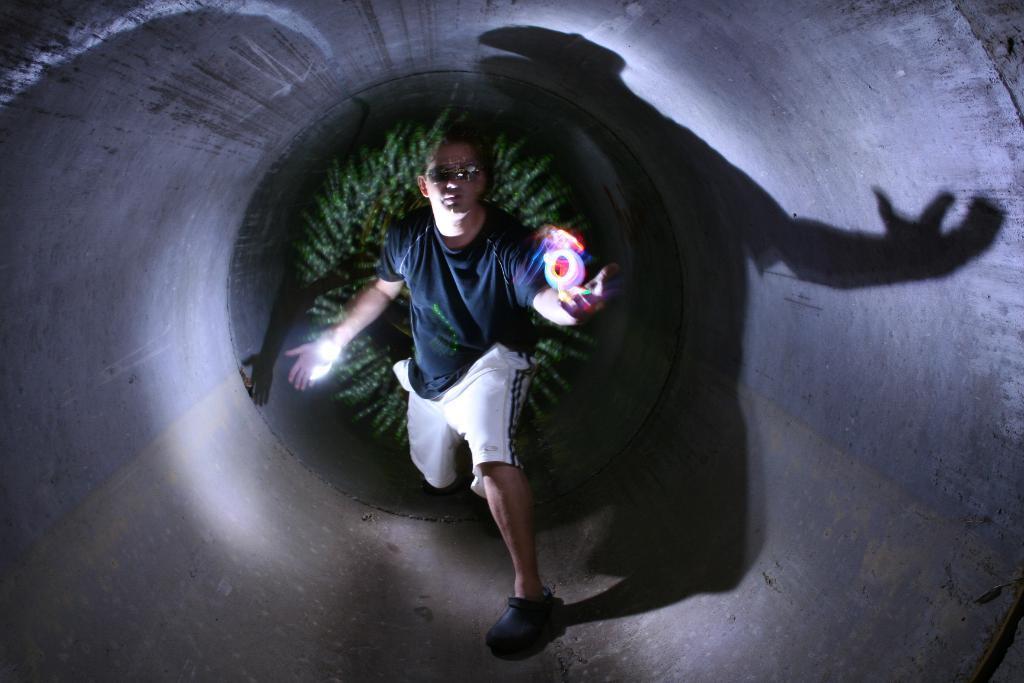Could you give a brief overview of what you see in this image? In this picture we can see a man wore goggles, shoes and standing and some objects and in the background we can see trees. 